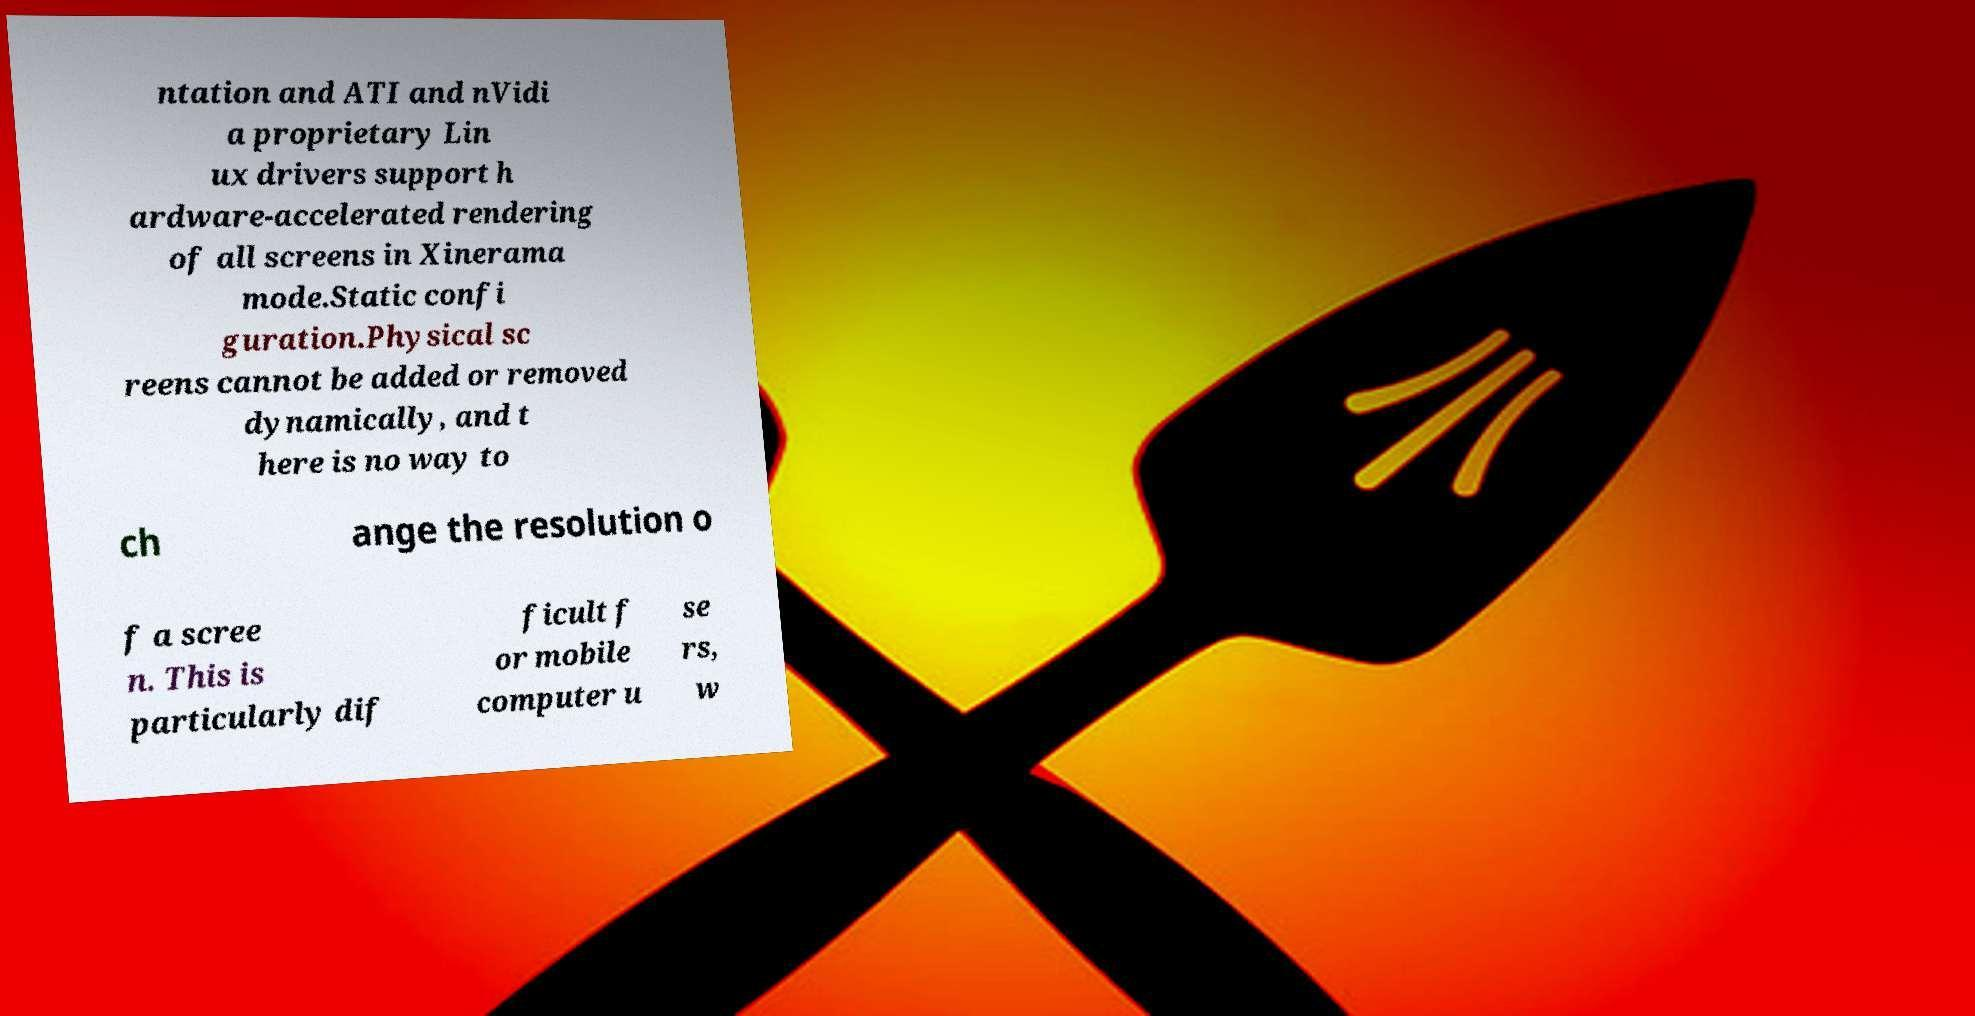Please identify and transcribe the text found in this image. ntation and ATI and nVidi a proprietary Lin ux drivers support h ardware-accelerated rendering of all screens in Xinerama mode.Static confi guration.Physical sc reens cannot be added or removed dynamically, and t here is no way to ch ange the resolution o f a scree n. This is particularly dif ficult f or mobile computer u se rs, w 